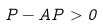Convert formula to latex. <formula><loc_0><loc_0><loc_500><loc_500>P - A P > 0</formula> 